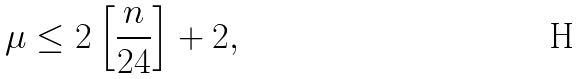Convert formula to latex. <formula><loc_0><loc_0><loc_500><loc_500>\mu \leq 2 \left [ \frac { n } { 2 4 } \right ] + 2 ,</formula> 